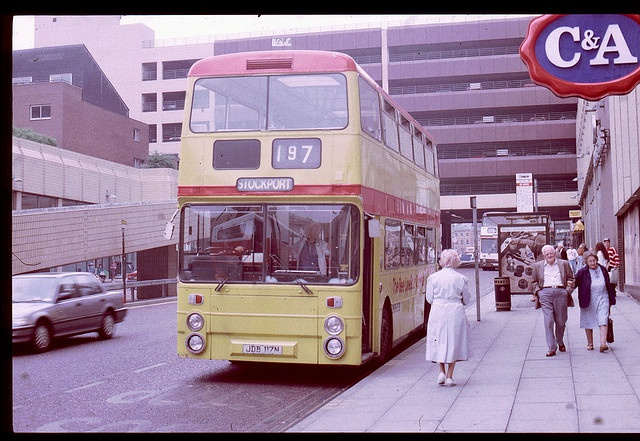Describe the objects in this image and their specific colors. I can see bus in black, darkgray, lightgray, and tan tones, car in black, lavender, and purple tones, people in black, lavender, darkgray, and violet tones, people in black, violet, and gray tones, and people in black, purple, gray, and lavender tones in this image. 